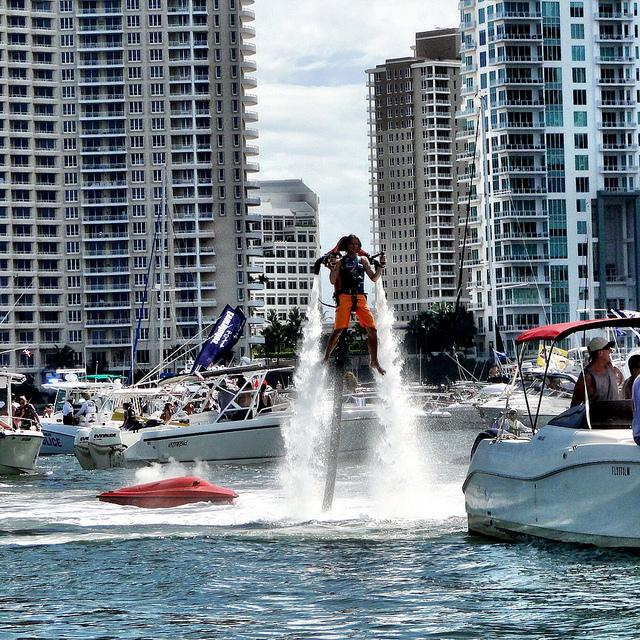What power allows the man to to airborne? water 